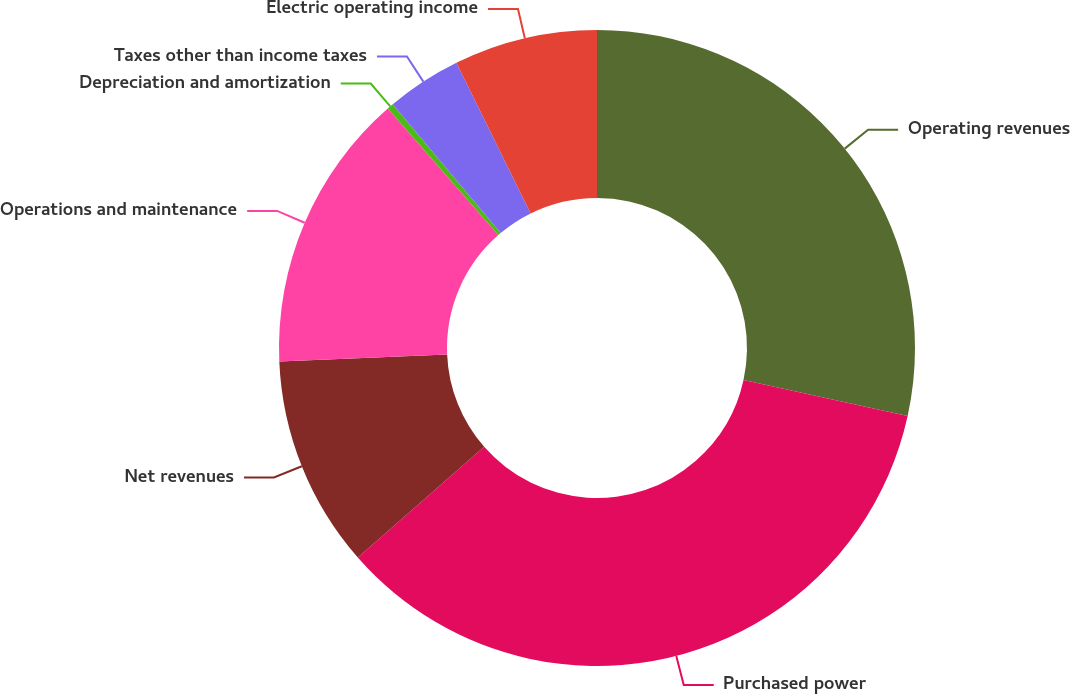Convert chart to OTSL. <chart><loc_0><loc_0><loc_500><loc_500><pie_chart><fcel>Operating revenues<fcel>Purchased power<fcel>Net revenues<fcel>Operations and maintenance<fcel>Depreciation and amortization<fcel>Taxes other than income taxes<fcel>Electric operating income<nl><fcel>28.43%<fcel>35.12%<fcel>10.77%<fcel>14.25%<fcel>0.33%<fcel>3.81%<fcel>7.29%<nl></chart> 